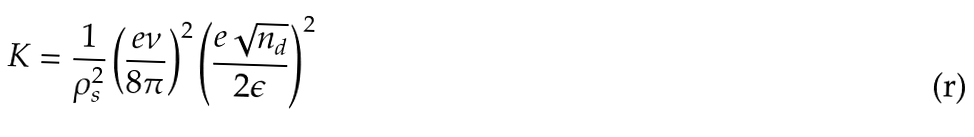<formula> <loc_0><loc_0><loc_500><loc_500>K = \frac { 1 } { \rho _ { s } ^ { 2 } } \left ( \frac { e \nu } { 8 \pi } \right ) ^ { 2 } \left ( \frac { e \sqrt { n _ { d } } } { 2 \epsilon } \right ) ^ { 2 }</formula> 